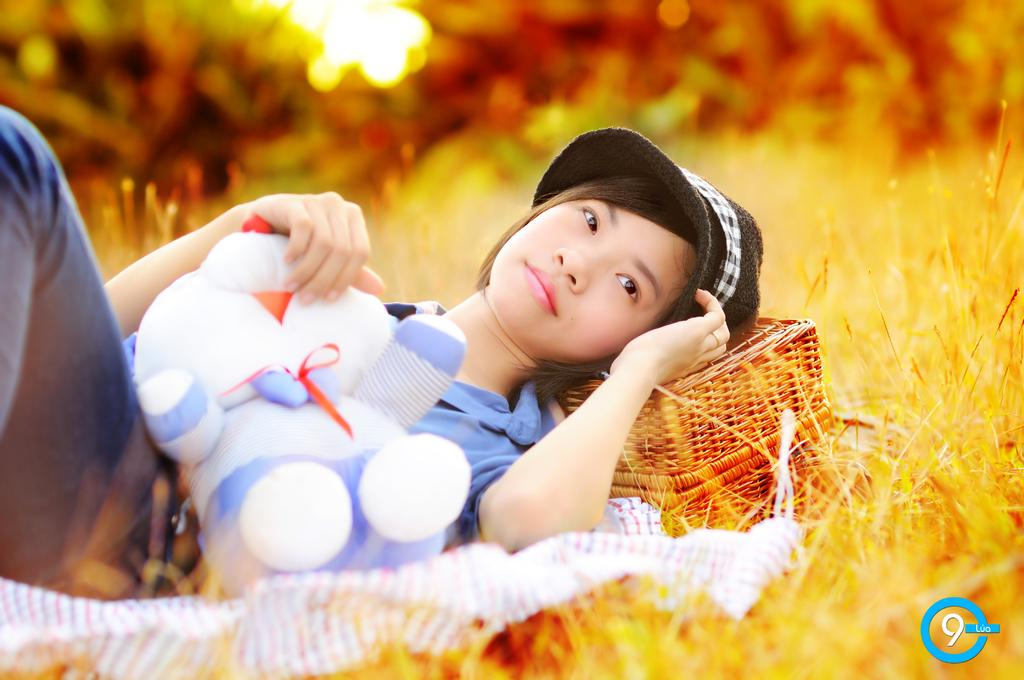Who or what is in the image? There is a person in the image. What is the person holding? The person is holding a teddy bear. What else can be seen in the image? There is a basket and dry grass present in the image. How would you describe the background of the image? The background of the image has yellow and orange colors. Reasoning: Let' Let's think step by step in order to produce the conversation. We start by identifying the main subject in the image, which is the person. Then, we expand the conversation to include other items that are also visible, such as the teddy bear, basket, and dry grass. Each question is designed to elicit a specific detail about the image that is known from the provided facts. We avoid yes/no questions and ensure that the language is simple and clear. Absurd Question/Answer: What is the shortest route to the sink in the image? There is no sink present in the image, so it is not possible to determine the shortest route to one. What is the distance between the person and the sink in the image? There is no sink present in the image, so it is not possible to determine the distance between the person and one. 